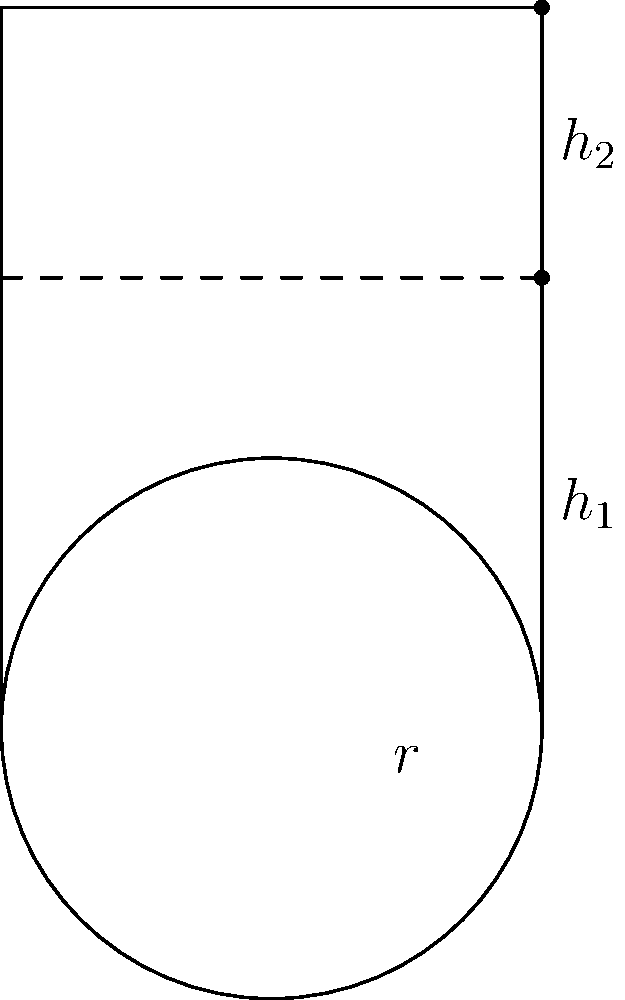As a board game designer, you're creating cylindrical dice containers with a fixed radius of 3 cm. You have two container heights: 5 cm and 8 cm. Calculate the difference in volume between these two containers. How much additional dice storage space does the taller container provide compared to the shorter one? Let's approach this step-by-step:

1. The volume of a cylinder is given by the formula $V = \pi r^2 h$, where $r$ is the radius and $h$ is the height.

2. We have two cylinders with the same radius $(r = 3$ cm$)$ but different heights:
   - $h_1 = 5$ cm
   - $h_2 = 8$ cm

3. Let's calculate the volume of each cylinder:

   For $h_1$: $V_1 = \pi (3 \text{ cm})^2 (5 \text{ cm}) = 45\pi \text{ cm}^3$
   
   For $h_2$: $V_2 = \pi (3 \text{ cm})^2 (8 \text{ cm}) = 72\pi \text{ cm}^3$

4. To find the difference in volume, we subtract $V_1$ from $V_2$:

   $\Delta V = V_2 - V_1 = 72\pi \text{ cm}^3 - 45\pi \text{ cm}^3 = 27\pi \text{ cm}^3$

5. To get a numerical value, we can use $\pi \approx 3.14159$:

   $\Delta V \approx 27 \times 3.14159 \text{ cm}^3 \approx 84.82 \text{ cm}^3$

Thus, the taller container provides approximately 84.82 cubic centimeters of additional dice storage space.
Answer: $27\pi \text{ cm}^3$ (or approximately $84.82 \text{ cm}^3$) 